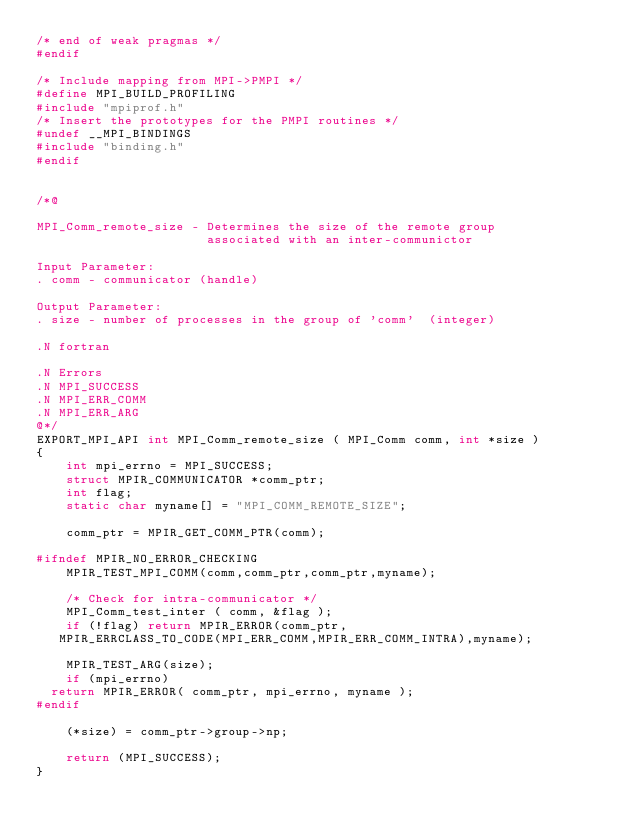Convert code to text. <code><loc_0><loc_0><loc_500><loc_500><_C_>/* end of weak pragmas */
#endif

/* Include mapping from MPI->PMPI */
#define MPI_BUILD_PROFILING
#include "mpiprof.h"
/* Insert the prototypes for the PMPI routines */
#undef __MPI_BINDINGS
#include "binding.h"
#endif


/*@

MPI_Comm_remote_size - Determines the size of the remote group 
                       associated with an inter-communictor

Input Parameter:
. comm - communicator (handle) 

Output Parameter:
. size - number of processes in the group of 'comm'  (integer) 

.N fortran

.N Errors
.N MPI_SUCCESS
.N MPI_ERR_COMM
.N MPI_ERR_ARG
@*/
EXPORT_MPI_API int MPI_Comm_remote_size ( MPI_Comm comm, int *size )
{
    int mpi_errno = MPI_SUCCESS;
    struct MPIR_COMMUNICATOR *comm_ptr;
    int flag;
    static char myname[] = "MPI_COMM_REMOTE_SIZE";

    comm_ptr = MPIR_GET_COMM_PTR(comm);

#ifndef MPIR_NO_ERROR_CHECKING
    MPIR_TEST_MPI_COMM(comm,comm_ptr,comm_ptr,myname);

    /* Check for intra-communicator */
    MPI_Comm_test_inter ( comm, &flag );
    if (!flag) return MPIR_ERROR(comm_ptr,
	 MPIR_ERRCLASS_TO_CODE(MPI_ERR_COMM,MPIR_ERR_COMM_INTRA),myname);

    MPIR_TEST_ARG(size);
    if (mpi_errno)
	return MPIR_ERROR( comm_ptr, mpi_errno, myname );
#endif

    (*size) = comm_ptr->group->np;

    return (MPI_SUCCESS);
}
</code> 